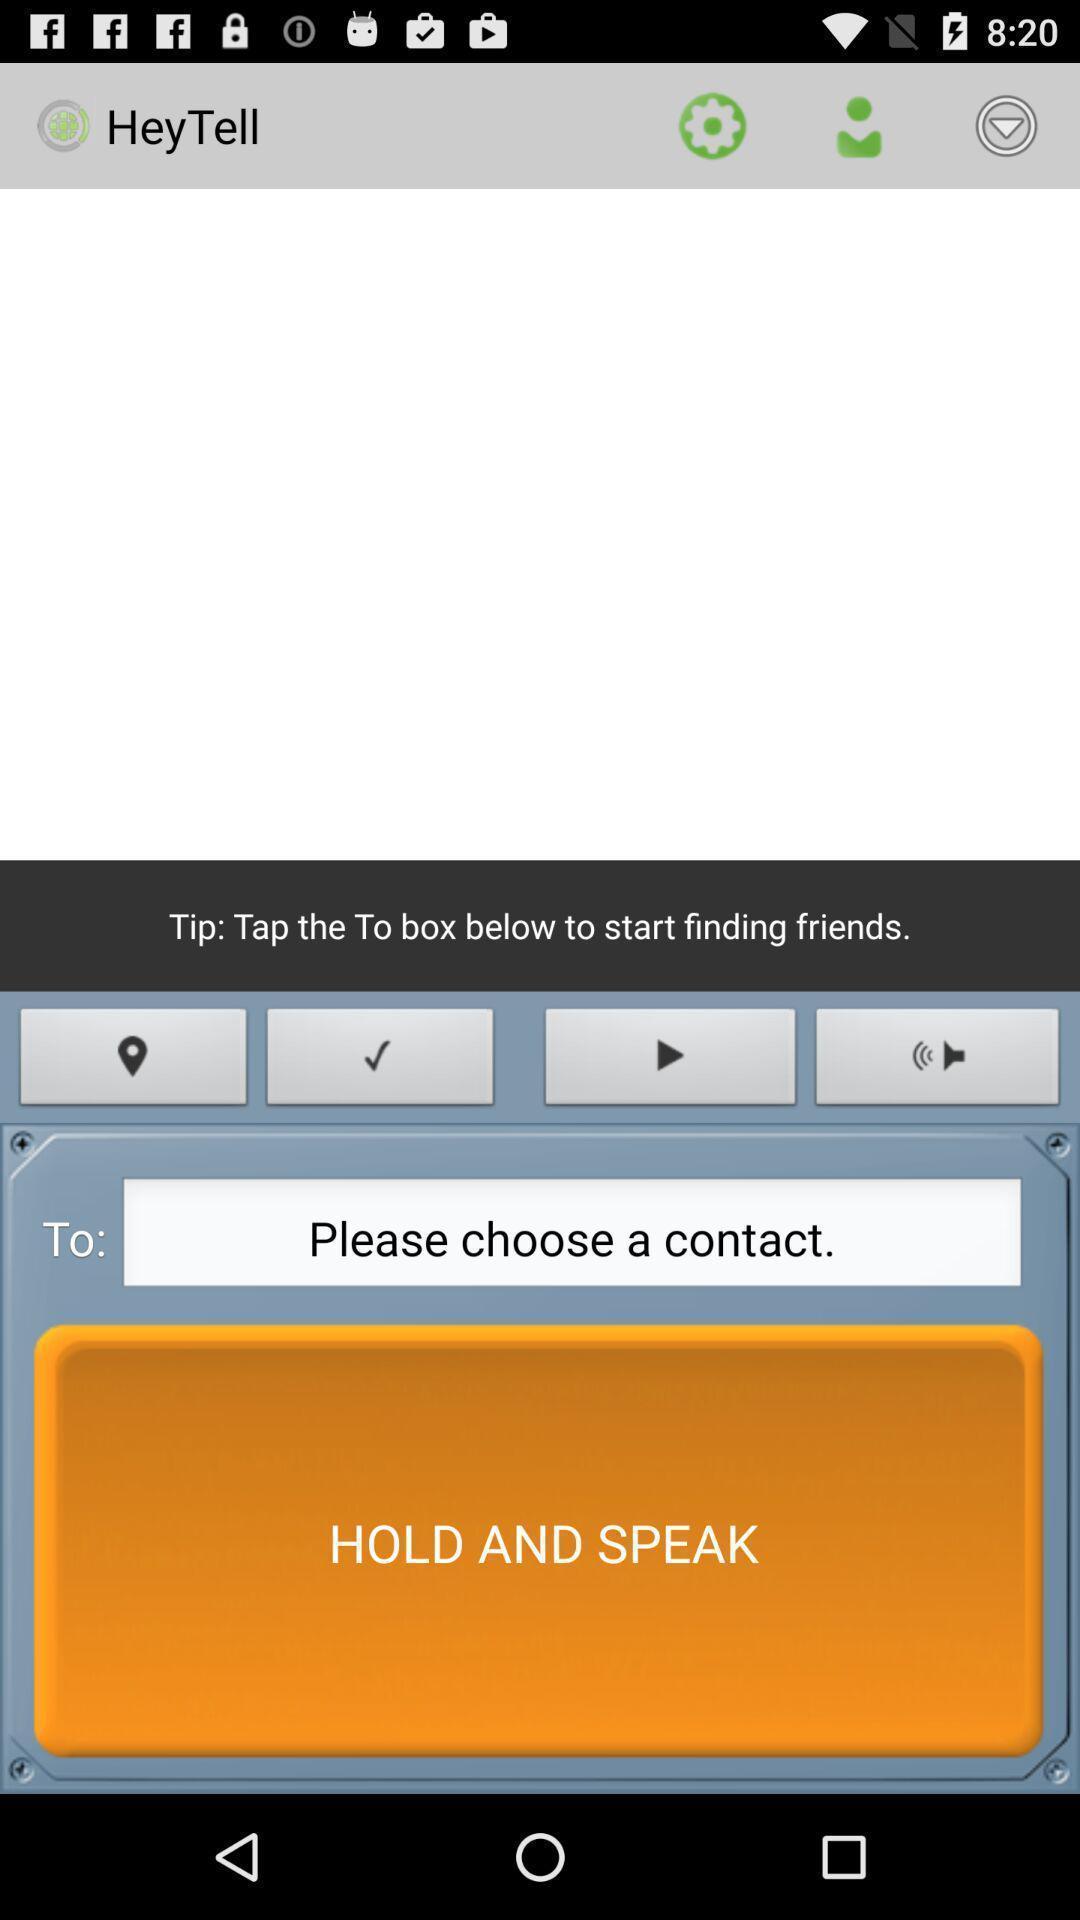Summarize the information in this screenshot. Screen shows hold and speak with a communication application. 